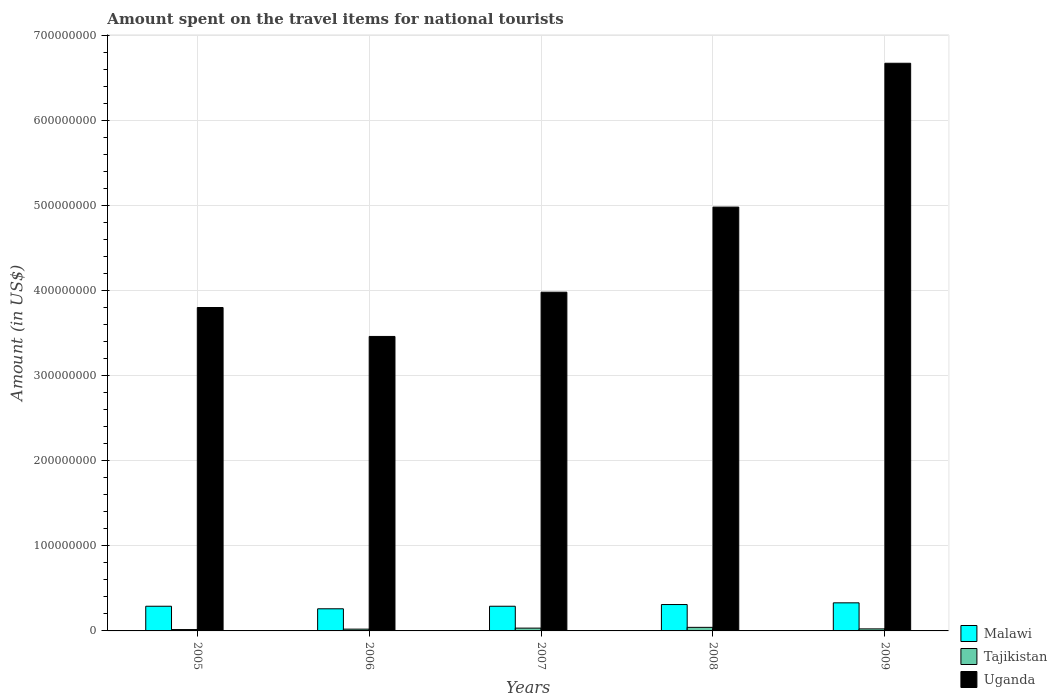Are the number of bars per tick equal to the number of legend labels?
Keep it short and to the point. Yes. Are the number of bars on each tick of the X-axis equal?
Provide a short and direct response. Yes. How many bars are there on the 1st tick from the left?
Your answer should be compact. 3. How many bars are there on the 5th tick from the right?
Give a very brief answer. 3. What is the label of the 3rd group of bars from the left?
Your response must be concise. 2007. In how many cases, is the number of bars for a given year not equal to the number of legend labels?
Provide a succinct answer. 0. What is the amount spent on the travel items for national tourists in Tajikistan in 2009?
Your answer should be compact. 2.40e+06. Across all years, what is the maximum amount spent on the travel items for national tourists in Tajikistan?
Provide a succinct answer. 4.20e+06. Across all years, what is the minimum amount spent on the travel items for national tourists in Malawi?
Ensure brevity in your answer.  2.60e+07. What is the total amount spent on the travel items for national tourists in Malawi in the graph?
Your answer should be compact. 1.48e+08. What is the difference between the amount spent on the travel items for national tourists in Uganda in 2005 and that in 2009?
Provide a short and direct response. -2.87e+08. What is the difference between the amount spent on the travel items for national tourists in Uganda in 2005 and the amount spent on the travel items for national tourists in Malawi in 2009?
Offer a very short reply. 3.47e+08. What is the average amount spent on the travel items for national tourists in Uganda per year?
Offer a very short reply. 4.58e+08. In the year 2006, what is the difference between the amount spent on the travel items for national tourists in Uganda and amount spent on the travel items for national tourists in Tajikistan?
Your answer should be very brief. 3.44e+08. In how many years, is the amount spent on the travel items for national tourists in Malawi greater than 480000000 US$?
Your response must be concise. 0. What is the ratio of the amount spent on the travel items for national tourists in Uganda in 2005 to that in 2009?
Your answer should be compact. 0.57. Is the amount spent on the travel items for national tourists in Uganda in 2006 less than that in 2007?
Give a very brief answer. Yes. Is the difference between the amount spent on the travel items for national tourists in Uganda in 2006 and 2009 greater than the difference between the amount spent on the travel items for national tourists in Tajikistan in 2006 and 2009?
Provide a succinct answer. No. What is the difference between the highest and the second highest amount spent on the travel items for national tourists in Uganda?
Keep it short and to the point. 1.69e+08. What is the difference between the highest and the lowest amount spent on the travel items for national tourists in Malawi?
Make the answer very short. 7.00e+06. What does the 1st bar from the left in 2007 represents?
Your answer should be compact. Malawi. What does the 2nd bar from the right in 2006 represents?
Make the answer very short. Tajikistan. Is it the case that in every year, the sum of the amount spent on the travel items for national tourists in Tajikistan and amount spent on the travel items for national tourists in Uganda is greater than the amount spent on the travel items for national tourists in Malawi?
Your answer should be compact. Yes. How many bars are there?
Ensure brevity in your answer.  15. How many years are there in the graph?
Offer a very short reply. 5. What is the difference between two consecutive major ticks on the Y-axis?
Provide a short and direct response. 1.00e+08. Are the values on the major ticks of Y-axis written in scientific E-notation?
Keep it short and to the point. No. How are the legend labels stacked?
Give a very brief answer. Vertical. What is the title of the graph?
Offer a terse response. Amount spent on the travel items for national tourists. What is the Amount (in US$) in Malawi in 2005?
Give a very brief answer. 2.90e+07. What is the Amount (in US$) in Tajikistan in 2005?
Your answer should be very brief. 1.60e+06. What is the Amount (in US$) in Uganda in 2005?
Keep it short and to the point. 3.80e+08. What is the Amount (in US$) of Malawi in 2006?
Offer a very short reply. 2.60e+07. What is the Amount (in US$) of Tajikistan in 2006?
Give a very brief answer. 2.10e+06. What is the Amount (in US$) of Uganda in 2006?
Ensure brevity in your answer.  3.46e+08. What is the Amount (in US$) of Malawi in 2007?
Your answer should be compact. 2.90e+07. What is the Amount (in US$) of Tajikistan in 2007?
Provide a succinct answer. 3.30e+06. What is the Amount (in US$) of Uganda in 2007?
Keep it short and to the point. 3.98e+08. What is the Amount (in US$) in Malawi in 2008?
Offer a very short reply. 3.10e+07. What is the Amount (in US$) in Tajikistan in 2008?
Provide a succinct answer. 4.20e+06. What is the Amount (in US$) in Uganda in 2008?
Keep it short and to the point. 4.98e+08. What is the Amount (in US$) in Malawi in 2009?
Ensure brevity in your answer.  3.30e+07. What is the Amount (in US$) of Tajikistan in 2009?
Give a very brief answer. 2.40e+06. What is the Amount (in US$) of Uganda in 2009?
Provide a short and direct response. 6.67e+08. Across all years, what is the maximum Amount (in US$) in Malawi?
Provide a succinct answer. 3.30e+07. Across all years, what is the maximum Amount (in US$) in Tajikistan?
Your response must be concise. 4.20e+06. Across all years, what is the maximum Amount (in US$) of Uganda?
Offer a terse response. 6.67e+08. Across all years, what is the minimum Amount (in US$) of Malawi?
Make the answer very short. 2.60e+07. Across all years, what is the minimum Amount (in US$) in Tajikistan?
Provide a succinct answer. 1.60e+06. Across all years, what is the minimum Amount (in US$) of Uganda?
Your answer should be compact. 3.46e+08. What is the total Amount (in US$) in Malawi in the graph?
Your response must be concise. 1.48e+08. What is the total Amount (in US$) of Tajikistan in the graph?
Provide a succinct answer. 1.36e+07. What is the total Amount (in US$) of Uganda in the graph?
Make the answer very short. 2.29e+09. What is the difference between the Amount (in US$) in Malawi in 2005 and that in 2006?
Make the answer very short. 3.00e+06. What is the difference between the Amount (in US$) in Tajikistan in 2005 and that in 2006?
Make the answer very short. -5.00e+05. What is the difference between the Amount (in US$) of Uganda in 2005 and that in 2006?
Ensure brevity in your answer.  3.40e+07. What is the difference between the Amount (in US$) in Tajikistan in 2005 and that in 2007?
Offer a terse response. -1.70e+06. What is the difference between the Amount (in US$) of Uganda in 2005 and that in 2007?
Give a very brief answer. -1.80e+07. What is the difference between the Amount (in US$) in Malawi in 2005 and that in 2008?
Your response must be concise. -2.00e+06. What is the difference between the Amount (in US$) in Tajikistan in 2005 and that in 2008?
Ensure brevity in your answer.  -2.60e+06. What is the difference between the Amount (in US$) in Uganda in 2005 and that in 2008?
Your answer should be very brief. -1.18e+08. What is the difference between the Amount (in US$) of Tajikistan in 2005 and that in 2009?
Your answer should be very brief. -8.00e+05. What is the difference between the Amount (in US$) of Uganda in 2005 and that in 2009?
Make the answer very short. -2.87e+08. What is the difference between the Amount (in US$) of Tajikistan in 2006 and that in 2007?
Provide a short and direct response. -1.20e+06. What is the difference between the Amount (in US$) in Uganda in 2006 and that in 2007?
Provide a short and direct response. -5.20e+07. What is the difference between the Amount (in US$) in Malawi in 2006 and that in 2008?
Give a very brief answer. -5.00e+06. What is the difference between the Amount (in US$) in Tajikistan in 2006 and that in 2008?
Make the answer very short. -2.10e+06. What is the difference between the Amount (in US$) in Uganda in 2006 and that in 2008?
Your answer should be compact. -1.52e+08. What is the difference between the Amount (in US$) of Malawi in 2006 and that in 2009?
Your answer should be very brief. -7.00e+06. What is the difference between the Amount (in US$) in Uganda in 2006 and that in 2009?
Give a very brief answer. -3.21e+08. What is the difference between the Amount (in US$) of Malawi in 2007 and that in 2008?
Make the answer very short. -2.00e+06. What is the difference between the Amount (in US$) in Tajikistan in 2007 and that in 2008?
Ensure brevity in your answer.  -9.00e+05. What is the difference between the Amount (in US$) in Uganda in 2007 and that in 2008?
Make the answer very short. -1.00e+08. What is the difference between the Amount (in US$) of Tajikistan in 2007 and that in 2009?
Your answer should be compact. 9.00e+05. What is the difference between the Amount (in US$) in Uganda in 2007 and that in 2009?
Provide a short and direct response. -2.69e+08. What is the difference between the Amount (in US$) in Malawi in 2008 and that in 2009?
Offer a very short reply. -2.00e+06. What is the difference between the Amount (in US$) in Tajikistan in 2008 and that in 2009?
Your response must be concise. 1.80e+06. What is the difference between the Amount (in US$) in Uganda in 2008 and that in 2009?
Give a very brief answer. -1.69e+08. What is the difference between the Amount (in US$) in Malawi in 2005 and the Amount (in US$) in Tajikistan in 2006?
Provide a succinct answer. 2.69e+07. What is the difference between the Amount (in US$) in Malawi in 2005 and the Amount (in US$) in Uganda in 2006?
Provide a succinct answer. -3.17e+08. What is the difference between the Amount (in US$) in Tajikistan in 2005 and the Amount (in US$) in Uganda in 2006?
Give a very brief answer. -3.44e+08. What is the difference between the Amount (in US$) of Malawi in 2005 and the Amount (in US$) of Tajikistan in 2007?
Ensure brevity in your answer.  2.57e+07. What is the difference between the Amount (in US$) of Malawi in 2005 and the Amount (in US$) of Uganda in 2007?
Give a very brief answer. -3.69e+08. What is the difference between the Amount (in US$) of Tajikistan in 2005 and the Amount (in US$) of Uganda in 2007?
Keep it short and to the point. -3.96e+08. What is the difference between the Amount (in US$) of Malawi in 2005 and the Amount (in US$) of Tajikistan in 2008?
Provide a succinct answer. 2.48e+07. What is the difference between the Amount (in US$) of Malawi in 2005 and the Amount (in US$) of Uganda in 2008?
Give a very brief answer. -4.69e+08. What is the difference between the Amount (in US$) of Tajikistan in 2005 and the Amount (in US$) of Uganda in 2008?
Give a very brief answer. -4.96e+08. What is the difference between the Amount (in US$) in Malawi in 2005 and the Amount (in US$) in Tajikistan in 2009?
Your response must be concise. 2.66e+07. What is the difference between the Amount (in US$) of Malawi in 2005 and the Amount (in US$) of Uganda in 2009?
Give a very brief answer. -6.38e+08. What is the difference between the Amount (in US$) of Tajikistan in 2005 and the Amount (in US$) of Uganda in 2009?
Ensure brevity in your answer.  -6.65e+08. What is the difference between the Amount (in US$) of Malawi in 2006 and the Amount (in US$) of Tajikistan in 2007?
Ensure brevity in your answer.  2.27e+07. What is the difference between the Amount (in US$) in Malawi in 2006 and the Amount (in US$) in Uganda in 2007?
Provide a succinct answer. -3.72e+08. What is the difference between the Amount (in US$) of Tajikistan in 2006 and the Amount (in US$) of Uganda in 2007?
Offer a terse response. -3.96e+08. What is the difference between the Amount (in US$) of Malawi in 2006 and the Amount (in US$) of Tajikistan in 2008?
Offer a very short reply. 2.18e+07. What is the difference between the Amount (in US$) of Malawi in 2006 and the Amount (in US$) of Uganda in 2008?
Provide a succinct answer. -4.72e+08. What is the difference between the Amount (in US$) in Tajikistan in 2006 and the Amount (in US$) in Uganda in 2008?
Keep it short and to the point. -4.96e+08. What is the difference between the Amount (in US$) in Malawi in 2006 and the Amount (in US$) in Tajikistan in 2009?
Give a very brief answer. 2.36e+07. What is the difference between the Amount (in US$) of Malawi in 2006 and the Amount (in US$) of Uganda in 2009?
Keep it short and to the point. -6.41e+08. What is the difference between the Amount (in US$) in Tajikistan in 2006 and the Amount (in US$) in Uganda in 2009?
Give a very brief answer. -6.65e+08. What is the difference between the Amount (in US$) in Malawi in 2007 and the Amount (in US$) in Tajikistan in 2008?
Your answer should be very brief. 2.48e+07. What is the difference between the Amount (in US$) in Malawi in 2007 and the Amount (in US$) in Uganda in 2008?
Your answer should be compact. -4.69e+08. What is the difference between the Amount (in US$) of Tajikistan in 2007 and the Amount (in US$) of Uganda in 2008?
Make the answer very short. -4.95e+08. What is the difference between the Amount (in US$) in Malawi in 2007 and the Amount (in US$) in Tajikistan in 2009?
Offer a very short reply. 2.66e+07. What is the difference between the Amount (in US$) in Malawi in 2007 and the Amount (in US$) in Uganda in 2009?
Make the answer very short. -6.38e+08. What is the difference between the Amount (in US$) in Tajikistan in 2007 and the Amount (in US$) in Uganda in 2009?
Offer a very short reply. -6.64e+08. What is the difference between the Amount (in US$) of Malawi in 2008 and the Amount (in US$) of Tajikistan in 2009?
Offer a very short reply. 2.86e+07. What is the difference between the Amount (in US$) of Malawi in 2008 and the Amount (in US$) of Uganda in 2009?
Offer a very short reply. -6.36e+08. What is the difference between the Amount (in US$) in Tajikistan in 2008 and the Amount (in US$) in Uganda in 2009?
Make the answer very short. -6.63e+08. What is the average Amount (in US$) of Malawi per year?
Give a very brief answer. 2.96e+07. What is the average Amount (in US$) of Tajikistan per year?
Give a very brief answer. 2.72e+06. What is the average Amount (in US$) in Uganda per year?
Provide a short and direct response. 4.58e+08. In the year 2005, what is the difference between the Amount (in US$) in Malawi and Amount (in US$) in Tajikistan?
Offer a terse response. 2.74e+07. In the year 2005, what is the difference between the Amount (in US$) in Malawi and Amount (in US$) in Uganda?
Your answer should be very brief. -3.51e+08. In the year 2005, what is the difference between the Amount (in US$) in Tajikistan and Amount (in US$) in Uganda?
Offer a terse response. -3.78e+08. In the year 2006, what is the difference between the Amount (in US$) in Malawi and Amount (in US$) in Tajikistan?
Keep it short and to the point. 2.39e+07. In the year 2006, what is the difference between the Amount (in US$) in Malawi and Amount (in US$) in Uganda?
Keep it short and to the point. -3.20e+08. In the year 2006, what is the difference between the Amount (in US$) in Tajikistan and Amount (in US$) in Uganda?
Your response must be concise. -3.44e+08. In the year 2007, what is the difference between the Amount (in US$) of Malawi and Amount (in US$) of Tajikistan?
Your answer should be very brief. 2.57e+07. In the year 2007, what is the difference between the Amount (in US$) in Malawi and Amount (in US$) in Uganda?
Ensure brevity in your answer.  -3.69e+08. In the year 2007, what is the difference between the Amount (in US$) in Tajikistan and Amount (in US$) in Uganda?
Provide a succinct answer. -3.95e+08. In the year 2008, what is the difference between the Amount (in US$) of Malawi and Amount (in US$) of Tajikistan?
Provide a succinct answer. 2.68e+07. In the year 2008, what is the difference between the Amount (in US$) of Malawi and Amount (in US$) of Uganda?
Keep it short and to the point. -4.67e+08. In the year 2008, what is the difference between the Amount (in US$) in Tajikistan and Amount (in US$) in Uganda?
Make the answer very short. -4.94e+08. In the year 2009, what is the difference between the Amount (in US$) of Malawi and Amount (in US$) of Tajikistan?
Offer a very short reply. 3.06e+07. In the year 2009, what is the difference between the Amount (in US$) in Malawi and Amount (in US$) in Uganda?
Your answer should be compact. -6.34e+08. In the year 2009, what is the difference between the Amount (in US$) in Tajikistan and Amount (in US$) in Uganda?
Give a very brief answer. -6.65e+08. What is the ratio of the Amount (in US$) in Malawi in 2005 to that in 2006?
Keep it short and to the point. 1.12. What is the ratio of the Amount (in US$) in Tajikistan in 2005 to that in 2006?
Make the answer very short. 0.76. What is the ratio of the Amount (in US$) of Uganda in 2005 to that in 2006?
Offer a very short reply. 1.1. What is the ratio of the Amount (in US$) in Tajikistan in 2005 to that in 2007?
Provide a succinct answer. 0.48. What is the ratio of the Amount (in US$) in Uganda in 2005 to that in 2007?
Offer a terse response. 0.95. What is the ratio of the Amount (in US$) in Malawi in 2005 to that in 2008?
Offer a terse response. 0.94. What is the ratio of the Amount (in US$) of Tajikistan in 2005 to that in 2008?
Provide a short and direct response. 0.38. What is the ratio of the Amount (in US$) of Uganda in 2005 to that in 2008?
Give a very brief answer. 0.76. What is the ratio of the Amount (in US$) in Malawi in 2005 to that in 2009?
Ensure brevity in your answer.  0.88. What is the ratio of the Amount (in US$) of Tajikistan in 2005 to that in 2009?
Provide a succinct answer. 0.67. What is the ratio of the Amount (in US$) of Uganda in 2005 to that in 2009?
Provide a succinct answer. 0.57. What is the ratio of the Amount (in US$) in Malawi in 2006 to that in 2007?
Provide a succinct answer. 0.9. What is the ratio of the Amount (in US$) of Tajikistan in 2006 to that in 2007?
Give a very brief answer. 0.64. What is the ratio of the Amount (in US$) of Uganda in 2006 to that in 2007?
Offer a very short reply. 0.87. What is the ratio of the Amount (in US$) of Malawi in 2006 to that in 2008?
Provide a succinct answer. 0.84. What is the ratio of the Amount (in US$) in Tajikistan in 2006 to that in 2008?
Provide a short and direct response. 0.5. What is the ratio of the Amount (in US$) of Uganda in 2006 to that in 2008?
Provide a short and direct response. 0.69. What is the ratio of the Amount (in US$) in Malawi in 2006 to that in 2009?
Your answer should be compact. 0.79. What is the ratio of the Amount (in US$) in Uganda in 2006 to that in 2009?
Your response must be concise. 0.52. What is the ratio of the Amount (in US$) in Malawi in 2007 to that in 2008?
Offer a terse response. 0.94. What is the ratio of the Amount (in US$) in Tajikistan in 2007 to that in 2008?
Provide a short and direct response. 0.79. What is the ratio of the Amount (in US$) of Uganda in 2007 to that in 2008?
Provide a short and direct response. 0.8. What is the ratio of the Amount (in US$) of Malawi in 2007 to that in 2009?
Offer a terse response. 0.88. What is the ratio of the Amount (in US$) of Tajikistan in 2007 to that in 2009?
Make the answer very short. 1.38. What is the ratio of the Amount (in US$) in Uganda in 2007 to that in 2009?
Keep it short and to the point. 0.6. What is the ratio of the Amount (in US$) in Malawi in 2008 to that in 2009?
Give a very brief answer. 0.94. What is the ratio of the Amount (in US$) in Uganda in 2008 to that in 2009?
Your answer should be very brief. 0.75. What is the difference between the highest and the second highest Amount (in US$) of Malawi?
Ensure brevity in your answer.  2.00e+06. What is the difference between the highest and the second highest Amount (in US$) in Tajikistan?
Your answer should be compact. 9.00e+05. What is the difference between the highest and the second highest Amount (in US$) in Uganda?
Offer a very short reply. 1.69e+08. What is the difference between the highest and the lowest Amount (in US$) in Tajikistan?
Keep it short and to the point. 2.60e+06. What is the difference between the highest and the lowest Amount (in US$) of Uganda?
Give a very brief answer. 3.21e+08. 